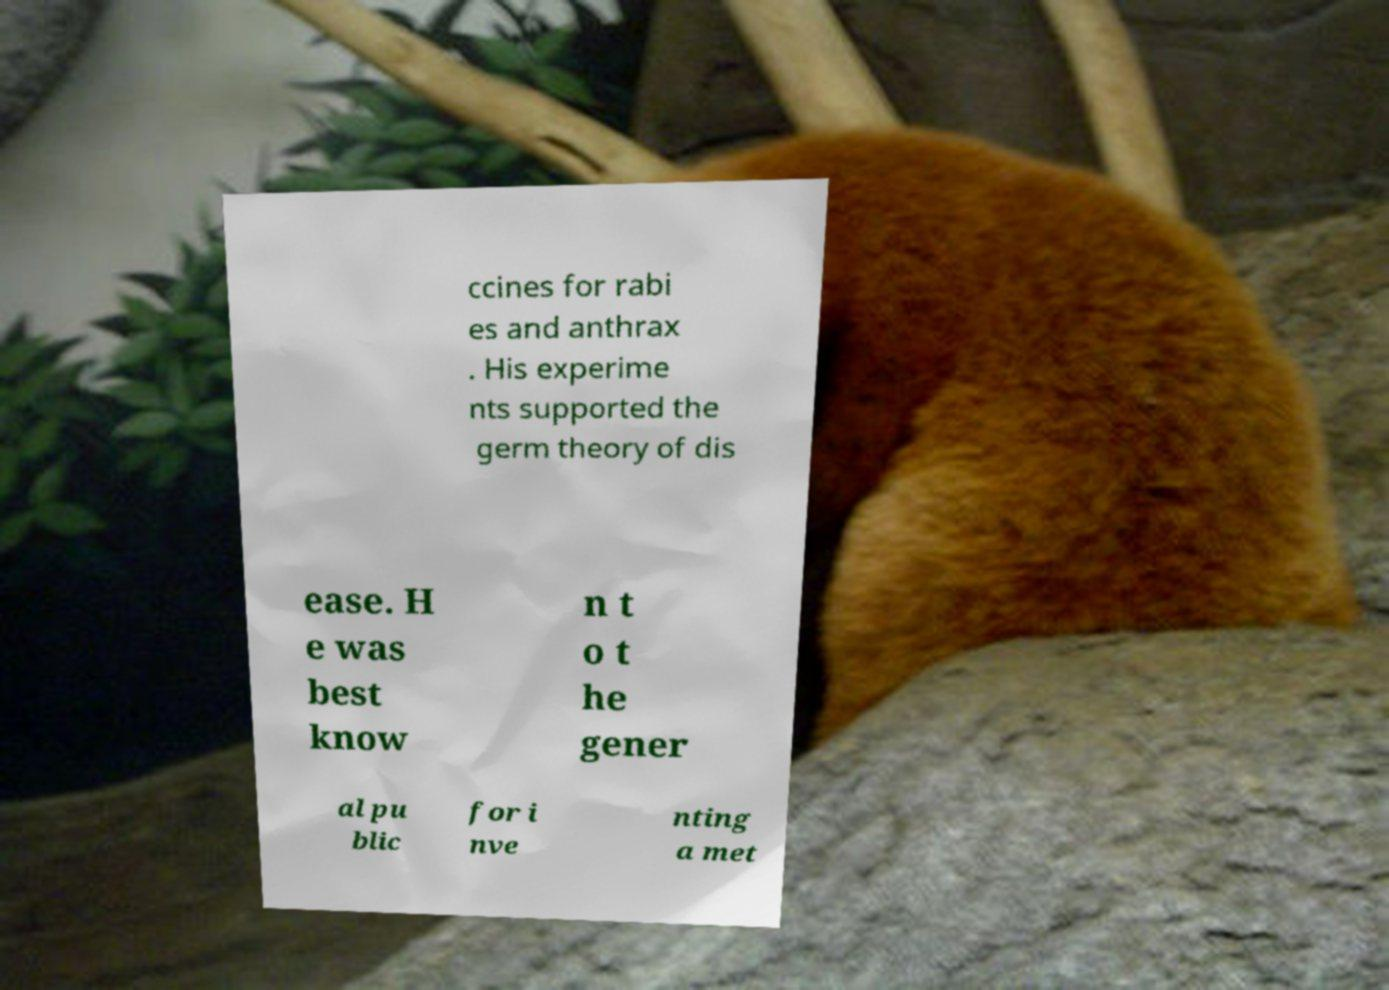What messages or text are displayed in this image? I need them in a readable, typed format. ccines for rabi es and anthrax . His experime nts supported the germ theory of dis ease. H e was best know n t o t he gener al pu blic for i nve nting a met 